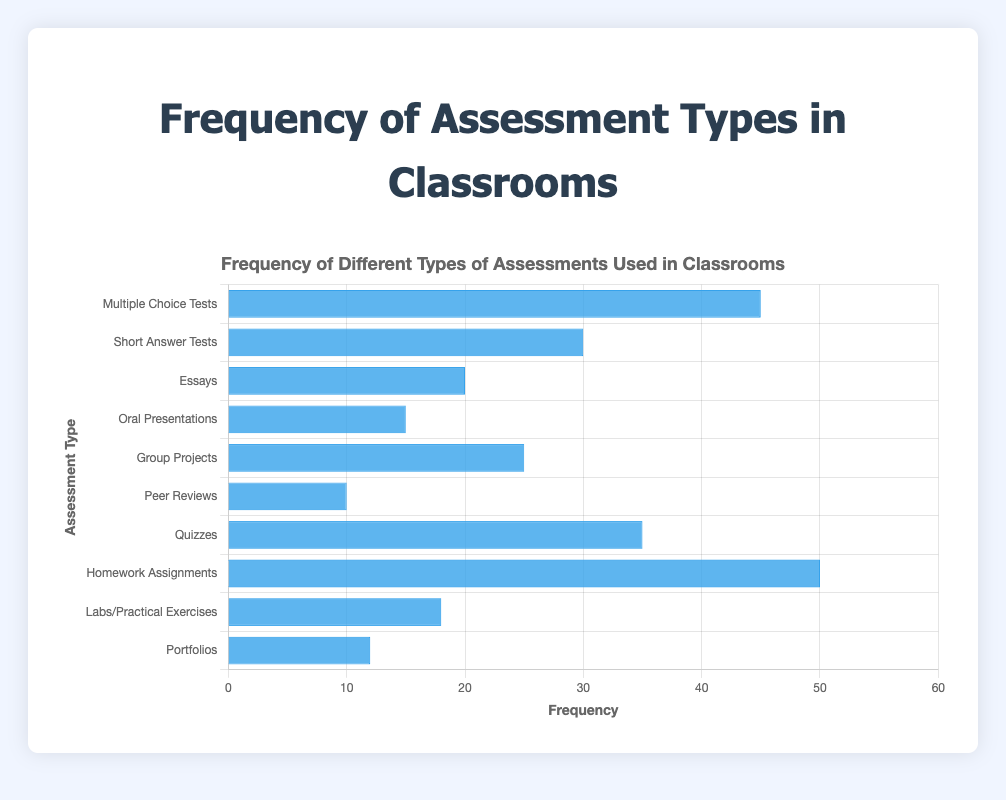Which assessment type is used most frequently in classrooms? "Homework Assignments" has the highest bar in the chart, indicating it is used the most frequently with a frequency of 50.
Answer: Homework Assignments Which two assessment types have a frequency of usage less than 15? The bars for "Peer Reviews" and "Portfolios" are the shortest, indicating frequencies of 10 and 12 respectively.
Answer: Peer Reviews and Portfolios How much more frequently are quizzes used compared to group projects? The frequency of quizzes (35) minus the frequency of group projects (25) is 10.
Answer: 10 What is the average frequency of “Short Answer Tests” and “Oral Presentations”? Sum the frequencies of short answer tests (30) and oral presentations (15) to get 45 and then divide by 2, resulting in 22.5.
Answer: 22.5 How many assessment types have a frequency greater than 20? The assessment types with frequencies greater than 20 are: "Multiple Choice Tests," "Short Answer Tests," "Quizzes," "Homework Assignments," and "Group Projects," making a total of 5.
Answer: 5 What is the median frequency of assessments? Sorting the frequencies: 10, 12, 15, 18, 20, 25, 30, 35, 45, 50, the middle value is 25.
Answer: 25 Which assessment type has a frequency closest to 20? "Essays" has a frequency of 20, which is closest to 20.
Answer: Essays Which two assessment types combined have a frequency of 55? "Short Answer Tests" (30) and "Group Projects" (25) combined have a frequency of 30 + 25 = 55.
Answer: Short Answer Tests and Group Projects 